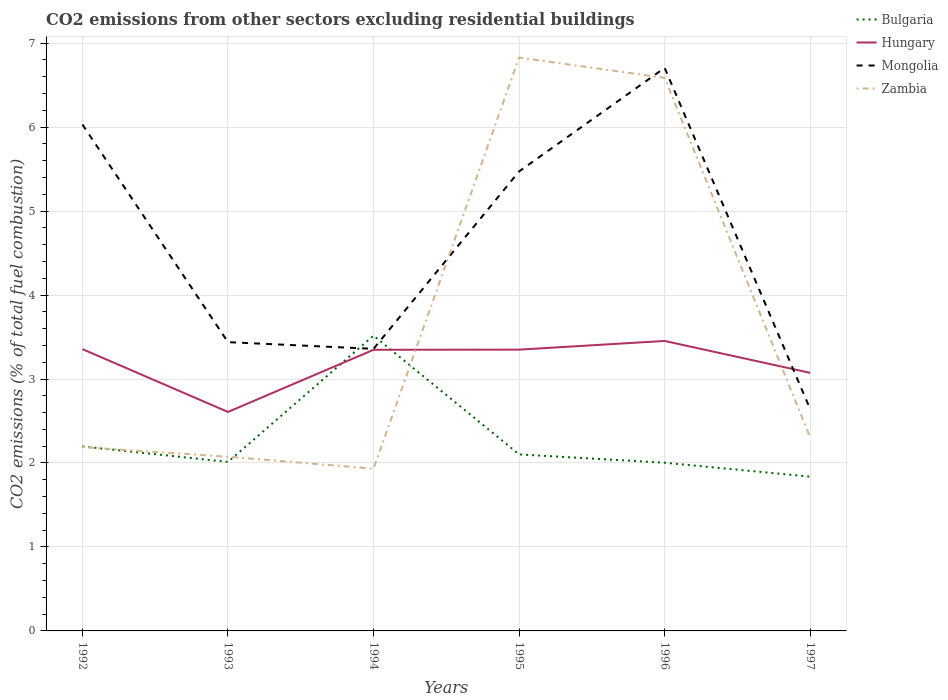Across all years, what is the maximum total CO2 emitted in Mongolia?
Your answer should be very brief. 2.64. In which year was the total CO2 emitted in Zambia maximum?
Provide a succinct answer. 1994. What is the total total CO2 emitted in Zambia in the graph?
Make the answer very short. -4.64. What is the difference between the highest and the second highest total CO2 emitted in Hungary?
Your answer should be compact. 0.85. Are the values on the major ticks of Y-axis written in scientific E-notation?
Ensure brevity in your answer.  No. Where does the legend appear in the graph?
Ensure brevity in your answer.  Top right. What is the title of the graph?
Offer a terse response. CO2 emissions from other sectors excluding residential buildings. What is the label or title of the X-axis?
Offer a very short reply. Years. What is the label or title of the Y-axis?
Your response must be concise. CO2 emissions (% of total fuel combustion). What is the CO2 emissions (% of total fuel combustion) in Bulgaria in 1992?
Offer a very short reply. 2.2. What is the CO2 emissions (% of total fuel combustion) of Hungary in 1992?
Your response must be concise. 3.36. What is the CO2 emissions (% of total fuel combustion) in Mongolia in 1992?
Provide a succinct answer. 6.03. What is the CO2 emissions (% of total fuel combustion) in Zambia in 1992?
Keep it short and to the point. 2.19. What is the CO2 emissions (% of total fuel combustion) in Bulgaria in 1993?
Make the answer very short. 2.01. What is the CO2 emissions (% of total fuel combustion) of Hungary in 1993?
Offer a terse response. 2.61. What is the CO2 emissions (% of total fuel combustion) of Mongolia in 1993?
Provide a short and direct response. 3.44. What is the CO2 emissions (% of total fuel combustion) in Zambia in 1993?
Provide a succinct answer. 2.07. What is the CO2 emissions (% of total fuel combustion) of Bulgaria in 1994?
Your response must be concise. 3.52. What is the CO2 emissions (% of total fuel combustion) of Hungary in 1994?
Keep it short and to the point. 3.35. What is the CO2 emissions (% of total fuel combustion) in Mongolia in 1994?
Offer a very short reply. 3.36. What is the CO2 emissions (% of total fuel combustion) in Zambia in 1994?
Ensure brevity in your answer.  1.93. What is the CO2 emissions (% of total fuel combustion) in Bulgaria in 1995?
Your answer should be very brief. 2.1. What is the CO2 emissions (% of total fuel combustion) in Hungary in 1995?
Give a very brief answer. 3.35. What is the CO2 emissions (% of total fuel combustion) of Mongolia in 1995?
Offer a terse response. 5.47. What is the CO2 emissions (% of total fuel combustion) in Zambia in 1995?
Give a very brief answer. 6.83. What is the CO2 emissions (% of total fuel combustion) of Bulgaria in 1996?
Make the answer very short. 2. What is the CO2 emissions (% of total fuel combustion) of Hungary in 1996?
Offer a terse response. 3.45. What is the CO2 emissions (% of total fuel combustion) of Mongolia in 1996?
Your answer should be very brief. 6.71. What is the CO2 emissions (% of total fuel combustion) in Zambia in 1996?
Offer a very short reply. 6.59. What is the CO2 emissions (% of total fuel combustion) in Bulgaria in 1997?
Give a very brief answer. 1.84. What is the CO2 emissions (% of total fuel combustion) in Hungary in 1997?
Your answer should be compact. 3.07. What is the CO2 emissions (% of total fuel combustion) of Mongolia in 1997?
Provide a short and direct response. 2.64. What is the CO2 emissions (% of total fuel combustion) of Zambia in 1997?
Provide a short and direct response. 2.3. Across all years, what is the maximum CO2 emissions (% of total fuel combustion) of Bulgaria?
Offer a terse response. 3.52. Across all years, what is the maximum CO2 emissions (% of total fuel combustion) in Hungary?
Keep it short and to the point. 3.45. Across all years, what is the maximum CO2 emissions (% of total fuel combustion) of Mongolia?
Provide a succinct answer. 6.71. Across all years, what is the maximum CO2 emissions (% of total fuel combustion) in Zambia?
Give a very brief answer. 6.83. Across all years, what is the minimum CO2 emissions (% of total fuel combustion) in Bulgaria?
Ensure brevity in your answer.  1.84. Across all years, what is the minimum CO2 emissions (% of total fuel combustion) in Hungary?
Provide a short and direct response. 2.61. Across all years, what is the minimum CO2 emissions (% of total fuel combustion) of Mongolia?
Offer a terse response. 2.64. Across all years, what is the minimum CO2 emissions (% of total fuel combustion) in Zambia?
Offer a very short reply. 1.93. What is the total CO2 emissions (% of total fuel combustion) in Bulgaria in the graph?
Your response must be concise. 13.67. What is the total CO2 emissions (% of total fuel combustion) in Hungary in the graph?
Provide a succinct answer. 19.19. What is the total CO2 emissions (% of total fuel combustion) in Mongolia in the graph?
Keep it short and to the point. 27.65. What is the total CO2 emissions (% of total fuel combustion) of Zambia in the graph?
Offer a very short reply. 21.92. What is the difference between the CO2 emissions (% of total fuel combustion) in Bulgaria in 1992 and that in 1993?
Ensure brevity in your answer.  0.18. What is the difference between the CO2 emissions (% of total fuel combustion) in Hungary in 1992 and that in 1993?
Your response must be concise. 0.75. What is the difference between the CO2 emissions (% of total fuel combustion) in Mongolia in 1992 and that in 1993?
Keep it short and to the point. 2.59. What is the difference between the CO2 emissions (% of total fuel combustion) in Zambia in 1992 and that in 1993?
Make the answer very short. 0.12. What is the difference between the CO2 emissions (% of total fuel combustion) of Bulgaria in 1992 and that in 1994?
Provide a short and direct response. -1.32. What is the difference between the CO2 emissions (% of total fuel combustion) in Hungary in 1992 and that in 1994?
Make the answer very short. 0.01. What is the difference between the CO2 emissions (% of total fuel combustion) in Mongolia in 1992 and that in 1994?
Ensure brevity in your answer.  2.67. What is the difference between the CO2 emissions (% of total fuel combustion) in Zambia in 1992 and that in 1994?
Give a very brief answer. 0.26. What is the difference between the CO2 emissions (% of total fuel combustion) of Bulgaria in 1992 and that in 1995?
Your answer should be very brief. 0.09. What is the difference between the CO2 emissions (% of total fuel combustion) in Hungary in 1992 and that in 1995?
Your answer should be very brief. 0.01. What is the difference between the CO2 emissions (% of total fuel combustion) in Mongolia in 1992 and that in 1995?
Offer a very short reply. 0.56. What is the difference between the CO2 emissions (% of total fuel combustion) of Zambia in 1992 and that in 1995?
Provide a succinct answer. -4.64. What is the difference between the CO2 emissions (% of total fuel combustion) in Bulgaria in 1992 and that in 1996?
Provide a succinct answer. 0.19. What is the difference between the CO2 emissions (% of total fuel combustion) of Hungary in 1992 and that in 1996?
Offer a terse response. -0.1. What is the difference between the CO2 emissions (% of total fuel combustion) in Mongolia in 1992 and that in 1996?
Give a very brief answer. -0.67. What is the difference between the CO2 emissions (% of total fuel combustion) in Zambia in 1992 and that in 1996?
Make the answer very short. -4.4. What is the difference between the CO2 emissions (% of total fuel combustion) in Bulgaria in 1992 and that in 1997?
Offer a very short reply. 0.36. What is the difference between the CO2 emissions (% of total fuel combustion) of Hungary in 1992 and that in 1997?
Offer a very short reply. 0.28. What is the difference between the CO2 emissions (% of total fuel combustion) in Mongolia in 1992 and that in 1997?
Your answer should be very brief. 3.39. What is the difference between the CO2 emissions (% of total fuel combustion) in Zambia in 1992 and that in 1997?
Provide a short and direct response. -0.11. What is the difference between the CO2 emissions (% of total fuel combustion) of Bulgaria in 1993 and that in 1994?
Offer a very short reply. -1.5. What is the difference between the CO2 emissions (% of total fuel combustion) of Hungary in 1993 and that in 1994?
Make the answer very short. -0.74. What is the difference between the CO2 emissions (% of total fuel combustion) of Mongolia in 1993 and that in 1994?
Make the answer very short. 0.08. What is the difference between the CO2 emissions (% of total fuel combustion) in Zambia in 1993 and that in 1994?
Provide a succinct answer. 0.14. What is the difference between the CO2 emissions (% of total fuel combustion) of Bulgaria in 1993 and that in 1995?
Make the answer very short. -0.09. What is the difference between the CO2 emissions (% of total fuel combustion) of Hungary in 1993 and that in 1995?
Ensure brevity in your answer.  -0.74. What is the difference between the CO2 emissions (% of total fuel combustion) in Mongolia in 1993 and that in 1995?
Your response must be concise. -2.03. What is the difference between the CO2 emissions (% of total fuel combustion) in Zambia in 1993 and that in 1995?
Your response must be concise. -4.75. What is the difference between the CO2 emissions (% of total fuel combustion) of Bulgaria in 1993 and that in 1996?
Offer a very short reply. 0.01. What is the difference between the CO2 emissions (% of total fuel combustion) in Hungary in 1993 and that in 1996?
Ensure brevity in your answer.  -0.85. What is the difference between the CO2 emissions (% of total fuel combustion) in Mongolia in 1993 and that in 1996?
Provide a succinct answer. -3.27. What is the difference between the CO2 emissions (% of total fuel combustion) in Zambia in 1993 and that in 1996?
Your answer should be very brief. -4.51. What is the difference between the CO2 emissions (% of total fuel combustion) of Bulgaria in 1993 and that in 1997?
Provide a short and direct response. 0.18. What is the difference between the CO2 emissions (% of total fuel combustion) in Hungary in 1993 and that in 1997?
Your answer should be very brief. -0.47. What is the difference between the CO2 emissions (% of total fuel combustion) in Mongolia in 1993 and that in 1997?
Offer a terse response. 0.8. What is the difference between the CO2 emissions (% of total fuel combustion) of Zambia in 1993 and that in 1997?
Provide a short and direct response. -0.23. What is the difference between the CO2 emissions (% of total fuel combustion) in Bulgaria in 1994 and that in 1995?
Provide a short and direct response. 1.41. What is the difference between the CO2 emissions (% of total fuel combustion) in Hungary in 1994 and that in 1995?
Your response must be concise. -0. What is the difference between the CO2 emissions (% of total fuel combustion) of Mongolia in 1994 and that in 1995?
Offer a terse response. -2.11. What is the difference between the CO2 emissions (% of total fuel combustion) of Zambia in 1994 and that in 1995?
Ensure brevity in your answer.  -4.9. What is the difference between the CO2 emissions (% of total fuel combustion) of Bulgaria in 1994 and that in 1996?
Ensure brevity in your answer.  1.51. What is the difference between the CO2 emissions (% of total fuel combustion) of Hungary in 1994 and that in 1996?
Offer a very short reply. -0.11. What is the difference between the CO2 emissions (% of total fuel combustion) in Mongolia in 1994 and that in 1996?
Offer a very short reply. -3.35. What is the difference between the CO2 emissions (% of total fuel combustion) of Zambia in 1994 and that in 1996?
Offer a very short reply. -4.65. What is the difference between the CO2 emissions (% of total fuel combustion) of Bulgaria in 1994 and that in 1997?
Your answer should be very brief. 1.68. What is the difference between the CO2 emissions (% of total fuel combustion) of Hungary in 1994 and that in 1997?
Make the answer very short. 0.27. What is the difference between the CO2 emissions (% of total fuel combustion) in Mongolia in 1994 and that in 1997?
Give a very brief answer. 0.72. What is the difference between the CO2 emissions (% of total fuel combustion) in Zambia in 1994 and that in 1997?
Provide a succinct answer. -0.37. What is the difference between the CO2 emissions (% of total fuel combustion) in Bulgaria in 1995 and that in 1996?
Ensure brevity in your answer.  0.1. What is the difference between the CO2 emissions (% of total fuel combustion) in Hungary in 1995 and that in 1996?
Offer a very short reply. -0.1. What is the difference between the CO2 emissions (% of total fuel combustion) in Mongolia in 1995 and that in 1996?
Offer a terse response. -1.23. What is the difference between the CO2 emissions (% of total fuel combustion) of Zambia in 1995 and that in 1996?
Your answer should be very brief. 0.24. What is the difference between the CO2 emissions (% of total fuel combustion) of Bulgaria in 1995 and that in 1997?
Offer a very short reply. 0.27. What is the difference between the CO2 emissions (% of total fuel combustion) of Hungary in 1995 and that in 1997?
Offer a terse response. 0.28. What is the difference between the CO2 emissions (% of total fuel combustion) of Mongolia in 1995 and that in 1997?
Provide a succinct answer. 2.83. What is the difference between the CO2 emissions (% of total fuel combustion) in Zambia in 1995 and that in 1997?
Make the answer very short. 4.53. What is the difference between the CO2 emissions (% of total fuel combustion) in Bulgaria in 1996 and that in 1997?
Ensure brevity in your answer.  0.17. What is the difference between the CO2 emissions (% of total fuel combustion) in Hungary in 1996 and that in 1997?
Offer a terse response. 0.38. What is the difference between the CO2 emissions (% of total fuel combustion) of Mongolia in 1996 and that in 1997?
Your answer should be compact. 4.06. What is the difference between the CO2 emissions (% of total fuel combustion) in Zambia in 1996 and that in 1997?
Make the answer very short. 4.28. What is the difference between the CO2 emissions (% of total fuel combustion) of Bulgaria in 1992 and the CO2 emissions (% of total fuel combustion) of Hungary in 1993?
Keep it short and to the point. -0.41. What is the difference between the CO2 emissions (% of total fuel combustion) in Bulgaria in 1992 and the CO2 emissions (% of total fuel combustion) in Mongolia in 1993?
Your answer should be compact. -1.24. What is the difference between the CO2 emissions (% of total fuel combustion) in Bulgaria in 1992 and the CO2 emissions (% of total fuel combustion) in Zambia in 1993?
Your answer should be very brief. 0.12. What is the difference between the CO2 emissions (% of total fuel combustion) in Hungary in 1992 and the CO2 emissions (% of total fuel combustion) in Mongolia in 1993?
Make the answer very short. -0.08. What is the difference between the CO2 emissions (% of total fuel combustion) of Hungary in 1992 and the CO2 emissions (% of total fuel combustion) of Zambia in 1993?
Offer a terse response. 1.28. What is the difference between the CO2 emissions (% of total fuel combustion) of Mongolia in 1992 and the CO2 emissions (% of total fuel combustion) of Zambia in 1993?
Make the answer very short. 3.96. What is the difference between the CO2 emissions (% of total fuel combustion) in Bulgaria in 1992 and the CO2 emissions (% of total fuel combustion) in Hungary in 1994?
Provide a succinct answer. -1.15. What is the difference between the CO2 emissions (% of total fuel combustion) in Bulgaria in 1992 and the CO2 emissions (% of total fuel combustion) in Mongolia in 1994?
Your answer should be very brief. -1.16. What is the difference between the CO2 emissions (% of total fuel combustion) in Bulgaria in 1992 and the CO2 emissions (% of total fuel combustion) in Zambia in 1994?
Your answer should be very brief. 0.26. What is the difference between the CO2 emissions (% of total fuel combustion) in Hungary in 1992 and the CO2 emissions (% of total fuel combustion) in Mongolia in 1994?
Make the answer very short. -0. What is the difference between the CO2 emissions (% of total fuel combustion) of Hungary in 1992 and the CO2 emissions (% of total fuel combustion) of Zambia in 1994?
Provide a short and direct response. 1.42. What is the difference between the CO2 emissions (% of total fuel combustion) of Mongolia in 1992 and the CO2 emissions (% of total fuel combustion) of Zambia in 1994?
Your answer should be compact. 4.1. What is the difference between the CO2 emissions (% of total fuel combustion) in Bulgaria in 1992 and the CO2 emissions (% of total fuel combustion) in Hungary in 1995?
Ensure brevity in your answer.  -1.15. What is the difference between the CO2 emissions (% of total fuel combustion) in Bulgaria in 1992 and the CO2 emissions (% of total fuel combustion) in Mongolia in 1995?
Make the answer very short. -3.28. What is the difference between the CO2 emissions (% of total fuel combustion) in Bulgaria in 1992 and the CO2 emissions (% of total fuel combustion) in Zambia in 1995?
Your response must be concise. -4.63. What is the difference between the CO2 emissions (% of total fuel combustion) in Hungary in 1992 and the CO2 emissions (% of total fuel combustion) in Mongolia in 1995?
Offer a terse response. -2.12. What is the difference between the CO2 emissions (% of total fuel combustion) of Hungary in 1992 and the CO2 emissions (% of total fuel combustion) of Zambia in 1995?
Give a very brief answer. -3.47. What is the difference between the CO2 emissions (% of total fuel combustion) in Mongolia in 1992 and the CO2 emissions (% of total fuel combustion) in Zambia in 1995?
Your answer should be very brief. -0.8. What is the difference between the CO2 emissions (% of total fuel combustion) of Bulgaria in 1992 and the CO2 emissions (% of total fuel combustion) of Hungary in 1996?
Keep it short and to the point. -1.26. What is the difference between the CO2 emissions (% of total fuel combustion) in Bulgaria in 1992 and the CO2 emissions (% of total fuel combustion) in Mongolia in 1996?
Provide a short and direct response. -4.51. What is the difference between the CO2 emissions (% of total fuel combustion) in Bulgaria in 1992 and the CO2 emissions (% of total fuel combustion) in Zambia in 1996?
Offer a terse response. -4.39. What is the difference between the CO2 emissions (% of total fuel combustion) of Hungary in 1992 and the CO2 emissions (% of total fuel combustion) of Mongolia in 1996?
Make the answer very short. -3.35. What is the difference between the CO2 emissions (% of total fuel combustion) of Hungary in 1992 and the CO2 emissions (% of total fuel combustion) of Zambia in 1996?
Your answer should be compact. -3.23. What is the difference between the CO2 emissions (% of total fuel combustion) of Mongolia in 1992 and the CO2 emissions (% of total fuel combustion) of Zambia in 1996?
Make the answer very short. -0.56. What is the difference between the CO2 emissions (% of total fuel combustion) of Bulgaria in 1992 and the CO2 emissions (% of total fuel combustion) of Hungary in 1997?
Ensure brevity in your answer.  -0.88. What is the difference between the CO2 emissions (% of total fuel combustion) in Bulgaria in 1992 and the CO2 emissions (% of total fuel combustion) in Mongolia in 1997?
Ensure brevity in your answer.  -0.44. What is the difference between the CO2 emissions (% of total fuel combustion) of Bulgaria in 1992 and the CO2 emissions (% of total fuel combustion) of Zambia in 1997?
Give a very brief answer. -0.11. What is the difference between the CO2 emissions (% of total fuel combustion) in Hungary in 1992 and the CO2 emissions (% of total fuel combustion) in Mongolia in 1997?
Your answer should be very brief. 0.72. What is the difference between the CO2 emissions (% of total fuel combustion) of Hungary in 1992 and the CO2 emissions (% of total fuel combustion) of Zambia in 1997?
Your answer should be very brief. 1.05. What is the difference between the CO2 emissions (% of total fuel combustion) in Mongolia in 1992 and the CO2 emissions (% of total fuel combustion) in Zambia in 1997?
Your answer should be very brief. 3.73. What is the difference between the CO2 emissions (% of total fuel combustion) of Bulgaria in 1993 and the CO2 emissions (% of total fuel combustion) of Hungary in 1994?
Ensure brevity in your answer.  -1.34. What is the difference between the CO2 emissions (% of total fuel combustion) of Bulgaria in 1993 and the CO2 emissions (% of total fuel combustion) of Mongolia in 1994?
Ensure brevity in your answer.  -1.35. What is the difference between the CO2 emissions (% of total fuel combustion) in Bulgaria in 1993 and the CO2 emissions (% of total fuel combustion) in Zambia in 1994?
Ensure brevity in your answer.  0.08. What is the difference between the CO2 emissions (% of total fuel combustion) in Hungary in 1993 and the CO2 emissions (% of total fuel combustion) in Mongolia in 1994?
Provide a short and direct response. -0.75. What is the difference between the CO2 emissions (% of total fuel combustion) in Hungary in 1993 and the CO2 emissions (% of total fuel combustion) in Zambia in 1994?
Offer a very short reply. 0.68. What is the difference between the CO2 emissions (% of total fuel combustion) in Mongolia in 1993 and the CO2 emissions (% of total fuel combustion) in Zambia in 1994?
Offer a terse response. 1.51. What is the difference between the CO2 emissions (% of total fuel combustion) of Bulgaria in 1993 and the CO2 emissions (% of total fuel combustion) of Hungary in 1995?
Your answer should be compact. -1.34. What is the difference between the CO2 emissions (% of total fuel combustion) of Bulgaria in 1993 and the CO2 emissions (% of total fuel combustion) of Mongolia in 1995?
Provide a succinct answer. -3.46. What is the difference between the CO2 emissions (% of total fuel combustion) of Bulgaria in 1993 and the CO2 emissions (% of total fuel combustion) of Zambia in 1995?
Offer a very short reply. -4.82. What is the difference between the CO2 emissions (% of total fuel combustion) of Hungary in 1993 and the CO2 emissions (% of total fuel combustion) of Mongolia in 1995?
Offer a very short reply. -2.86. What is the difference between the CO2 emissions (% of total fuel combustion) in Hungary in 1993 and the CO2 emissions (% of total fuel combustion) in Zambia in 1995?
Give a very brief answer. -4.22. What is the difference between the CO2 emissions (% of total fuel combustion) in Mongolia in 1993 and the CO2 emissions (% of total fuel combustion) in Zambia in 1995?
Offer a terse response. -3.39. What is the difference between the CO2 emissions (% of total fuel combustion) of Bulgaria in 1993 and the CO2 emissions (% of total fuel combustion) of Hungary in 1996?
Offer a very short reply. -1.44. What is the difference between the CO2 emissions (% of total fuel combustion) of Bulgaria in 1993 and the CO2 emissions (% of total fuel combustion) of Mongolia in 1996?
Offer a very short reply. -4.69. What is the difference between the CO2 emissions (% of total fuel combustion) in Bulgaria in 1993 and the CO2 emissions (% of total fuel combustion) in Zambia in 1996?
Give a very brief answer. -4.57. What is the difference between the CO2 emissions (% of total fuel combustion) of Hungary in 1993 and the CO2 emissions (% of total fuel combustion) of Mongolia in 1996?
Your answer should be very brief. -4.1. What is the difference between the CO2 emissions (% of total fuel combustion) of Hungary in 1993 and the CO2 emissions (% of total fuel combustion) of Zambia in 1996?
Make the answer very short. -3.98. What is the difference between the CO2 emissions (% of total fuel combustion) in Mongolia in 1993 and the CO2 emissions (% of total fuel combustion) in Zambia in 1996?
Provide a succinct answer. -3.15. What is the difference between the CO2 emissions (% of total fuel combustion) of Bulgaria in 1993 and the CO2 emissions (% of total fuel combustion) of Hungary in 1997?
Give a very brief answer. -1.06. What is the difference between the CO2 emissions (% of total fuel combustion) in Bulgaria in 1993 and the CO2 emissions (% of total fuel combustion) in Mongolia in 1997?
Keep it short and to the point. -0.63. What is the difference between the CO2 emissions (% of total fuel combustion) in Bulgaria in 1993 and the CO2 emissions (% of total fuel combustion) in Zambia in 1997?
Provide a short and direct response. -0.29. What is the difference between the CO2 emissions (% of total fuel combustion) of Hungary in 1993 and the CO2 emissions (% of total fuel combustion) of Mongolia in 1997?
Provide a succinct answer. -0.03. What is the difference between the CO2 emissions (% of total fuel combustion) in Hungary in 1993 and the CO2 emissions (% of total fuel combustion) in Zambia in 1997?
Your answer should be compact. 0.3. What is the difference between the CO2 emissions (% of total fuel combustion) of Mongolia in 1993 and the CO2 emissions (% of total fuel combustion) of Zambia in 1997?
Give a very brief answer. 1.14. What is the difference between the CO2 emissions (% of total fuel combustion) in Bulgaria in 1994 and the CO2 emissions (% of total fuel combustion) in Hungary in 1995?
Offer a terse response. 0.17. What is the difference between the CO2 emissions (% of total fuel combustion) in Bulgaria in 1994 and the CO2 emissions (% of total fuel combustion) in Mongolia in 1995?
Make the answer very short. -1.96. What is the difference between the CO2 emissions (% of total fuel combustion) in Bulgaria in 1994 and the CO2 emissions (% of total fuel combustion) in Zambia in 1995?
Your answer should be very brief. -3.31. What is the difference between the CO2 emissions (% of total fuel combustion) of Hungary in 1994 and the CO2 emissions (% of total fuel combustion) of Mongolia in 1995?
Your response must be concise. -2.12. What is the difference between the CO2 emissions (% of total fuel combustion) in Hungary in 1994 and the CO2 emissions (% of total fuel combustion) in Zambia in 1995?
Offer a terse response. -3.48. What is the difference between the CO2 emissions (% of total fuel combustion) of Mongolia in 1994 and the CO2 emissions (% of total fuel combustion) of Zambia in 1995?
Offer a very short reply. -3.47. What is the difference between the CO2 emissions (% of total fuel combustion) in Bulgaria in 1994 and the CO2 emissions (% of total fuel combustion) in Hungary in 1996?
Give a very brief answer. 0.06. What is the difference between the CO2 emissions (% of total fuel combustion) of Bulgaria in 1994 and the CO2 emissions (% of total fuel combustion) of Mongolia in 1996?
Your response must be concise. -3.19. What is the difference between the CO2 emissions (% of total fuel combustion) of Bulgaria in 1994 and the CO2 emissions (% of total fuel combustion) of Zambia in 1996?
Provide a succinct answer. -3.07. What is the difference between the CO2 emissions (% of total fuel combustion) in Hungary in 1994 and the CO2 emissions (% of total fuel combustion) in Mongolia in 1996?
Keep it short and to the point. -3.36. What is the difference between the CO2 emissions (% of total fuel combustion) in Hungary in 1994 and the CO2 emissions (% of total fuel combustion) in Zambia in 1996?
Provide a short and direct response. -3.24. What is the difference between the CO2 emissions (% of total fuel combustion) in Mongolia in 1994 and the CO2 emissions (% of total fuel combustion) in Zambia in 1996?
Give a very brief answer. -3.23. What is the difference between the CO2 emissions (% of total fuel combustion) in Bulgaria in 1994 and the CO2 emissions (% of total fuel combustion) in Hungary in 1997?
Offer a very short reply. 0.44. What is the difference between the CO2 emissions (% of total fuel combustion) of Bulgaria in 1994 and the CO2 emissions (% of total fuel combustion) of Mongolia in 1997?
Give a very brief answer. 0.88. What is the difference between the CO2 emissions (% of total fuel combustion) of Bulgaria in 1994 and the CO2 emissions (% of total fuel combustion) of Zambia in 1997?
Offer a very short reply. 1.21. What is the difference between the CO2 emissions (% of total fuel combustion) in Hungary in 1994 and the CO2 emissions (% of total fuel combustion) in Mongolia in 1997?
Your answer should be very brief. 0.71. What is the difference between the CO2 emissions (% of total fuel combustion) in Hungary in 1994 and the CO2 emissions (% of total fuel combustion) in Zambia in 1997?
Ensure brevity in your answer.  1.04. What is the difference between the CO2 emissions (% of total fuel combustion) of Mongolia in 1994 and the CO2 emissions (% of total fuel combustion) of Zambia in 1997?
Your response must be concise. 1.06. What is the difference between the CO2 emissions (% of total fuel combustion) of Bulgaria in 1995 and the CO2 emissions (% of total fuel combustion) of Hungary in 1996?
Provide a short and direct response. -1.35. What is the difference between the CO2 emissions (% of total fuel combustion) in Bulgaria in 1995 and the CO2 emissions (% of total fuel combustion) in Mongolia in 1996?
Ensure brevity in your answer.  -4.6. What is the difference between the CO2 emissions (% of total fuel combustion) in Bulgaria in 1995 and the CO2 emissions (% of total fuel combustion) in Zambia in 1996?
Ensure brevity in your answer.  -4.48. What is the difference between the CO2 emissions (% of total fuel combustion) of Hungary in 1995 and the CO2 emissions (% of total fuel combustion) of Mongolia in 1996?
Your response must be concise. -3.36. What is the difference between the CO2 emissions (% of total fuel combustion) in Hungary in 1995 and the CO2 emissions (% of total fuel combustion) in Zambia in 1996?
Provide a short and direct response. -3.24. What is the difference between the CO2 emissions (% of total fuel combustion) in Mongolia in 1995 and the CO2 emissions (% of total fuel combustion) in Zambia in 1996?
Give a very brief answer. -1.11. What is the difference between the CO2 emissions (% of total fuel combustion) in Bulgaria in 1995 and the CO2 emissions (% of total fuel combustion) in Hungary in 1997?
Your answer should be compact. -0.97. What is the difference between the CO2 emissions (% of total fuel combustion) in Bulgaria in 1995 and the CO2 emissions (% of total fuel combustion) in Mongolia in 1997?
Offer a very short reply. -0.54. What is the difference between the CO2 emissions (% of total fuel combustion) of Bulgaria in 1995 and the CO2 emissions (% of total fuel combustion) of Zambia in 1997?
Keep it short and to the point. -0.2. What is the difference between the CO2 emissions (% of total fuel combustion) in Hungary in 1995 and the CO2 emissions (% of total fuel combustion) in Mongolia in 1997?
Make the answer very short. 0.71. What is the difference between the CO2 emissions (% of total fuel combustion) in Hungary in 1995 and the CO2 emissions (% of total fuel combustion) in Zambia in 1997?
Give a very brief answer. 1.05. What is the difference between the CO2 emissions (% of total fuel combustion) in Mongolia in 1995 and the CO2 emissions (% of total fuel combustion) in Zambia in 1997?
Offer a very short reply. 3.17. What is the difference between the CO2 emissions (% of total fuel combustion) in Bulgaria in 1996 and the CO2 emissions (% of total fuel combustion) in Hungary in 1997?
Your response must be concise. -1.07. What is the difference between the CO2 emissions (% of total fuel combustion) of Bulgaria in 1996 and the CO2 emissions (% of total fuel combustion) of Mongolia in 1997?
Offer a very short reply. -0.64. What is the difference between the CO2 emissions (% of total fuel combustion) of Bulgaria in 1996 and the CO2 emissions (% of total fuel combustion) of Zambia in 1997?
Provide a short and direct response. -0.3. What is the difference between the CO2 emissions (% of total fuel combustion) of Hungary in 1996 and the CO2 emissions (% of total fuel combustion) of Mongolia in 1997?
Your answer should be very brief. 0.81. What is the difference between the CO2 emissions (% of total fuel combustion) of Hungary in 1996 and the CO2 emissions (% of total fuel combustion) of Zambia in 1997?
Provide a short and direct response. 1.15. What is the difference between the CO2 emissions (% of total fuel combustion) in Mongolia in 1996 and the CO2 emissions (% of total fuel combustion) in Zambia in 1997?
Make the answer very short. 4.4. What is the average CO2 emissions (% of total fuel combustion) of Bulgaria per year?
Offer a terse response. 2.28. What is the average CO2 emissions (% of total fuel combustion) of Hungary per year?
Your response must be concise. 3.2. What is the average CO2 emissions (% of total fuel combustion) in Mongolia per year?
Give a very brief answer. 4.61. What is the average CO2 emissions (% of total fuel combustion) in Zambia per year?
Provide a short and direct response. 3.65. In the year 1992, what is the difference between the CO2 emissions (% of total fuel combustion) in Bulgaria and CO2 emissions (% of total fuel combustion) in Hungary?
Make the answer very short. -1.16. In the year 1992, what is the difference between the CO2 emissions (% of total fuel combustion) of Bulgaria and CO2 emissions (% of total fuel combustion) of Mongolia?
Make the answer very short. -3.83. In the year 1992, what is the difference between the CO2 emissions (% of total fuel combustion) in Bulgaria and CO2 emissions (% of total fuel combustion) in Zambia?
Your answer should be very brief. 0.01. In the year 1992, what is the difference between the CO2 emissions (% of total fuel combustion) of Hungary and CO2 emissions (% of total fuel combustion) of Mongolia?
Provide a short and direct response. -2.68. In the year 1992, what is the difference between the CO2 emissions (% of total fuel combustion) of Hungary and CO2 emissions (% of total fuel combustion) of Zambia?
Offer a very short reply. 1.17. In the year 1992, what is the difference between the CO2 emissions (% of total fuel combustion) of Mongolia and CO2 emissions (% of total fuel combustion) of Zambia?
Ensure brevity in your answer.  3.84. In the year 1993, what is the difference between the CO2 emissions (% of total fuel combustion) of Bulgaria and CO2 emissions (% of total fuel combustion) of Hungary?
Provide a succinct answer. -0.6. In the year 1993, what is the difference between the CO2 emissions (% of total fuel combustion) in Bulgaria and CO2 emissions (% of total fuel combustion) in Mongolia?
Give a very brief answer. -1.43. In the year 1993, what is the difference between the CO2 emissions (% of total fuel combustion) in Bulgaria and CO2 emissions (% of total fuel combustion) in Zambia?
Keep it short and to the point. -0.06. In the year 1993, what is the difference between the CO2 emissions (% of total fuel combustion) in Hungary and CO2 emissions (% of total fuel combustion) in Mongolia?
Your answer should be compact. -0.83. In the year 1993, what is the difference between the CO2 emissions (% of total fuel combustion) in Hungary and CO2 emissions (% of total fuel combustion) in Zambia?
Provide a succinct answer. 0.53. In the year 1993, what is the difference between the CO2 emissions (% of total fuel combustion) of Mongolia and CO2 emissions (% of total fuel combustion) of Zambia?
Your answer should be compact. 1.36. In the year 1994, what is the difference between the CO2 emissions (% of total fuel combustion) of Bulgaria and CO2 emissions (% of total fuel combustion) of Hungary?
Your answer should be compact. 0.17. In the year 1994, what is the difference between the CO2 emissions (% of total fuel combustion) in Bulgaria and CO2 emissions (% of total fuel combustion) in Mongolia?
Your answer should be compact. 0.16. In the year 1994, what is the difference between the CO2 emissions (% of total fuel combustion) in Bulgaria and CO2 emissions (% of total fuel combustion) in Zambia?
Make the answer very short. 1.58. In the year 1994, what is the difference between the CO2 emissions (% of total fuel combustion) of Hungary and CO2 emissions (% of total fuel combustion) of Mongolia?
Provide a succinct answer. -0.01. In the year 1994, what is the difference between the CO2 emissions (% of total fuel combustion) of Hungary and CO2 emissions (% of total fuel combustion) of Zambia?
Give a very brief answer. 1.42. In the year 1994, what is the difference between the CO2 emissions (% of total fuel combustion) of Mongolia and CO2 emissions (% of total fuel combustion) of Zambia?
Provide a short and direct response. 1.43. In the year 1995, what is the difference between the CO2 emissions (% of total fuel combustion) of Bulgaria and CO2 emissions (% of total fuel combustion) of Hungary?
Keep it short and to the point. -1.25. In the year 1995, what is the difference between the CO2 emissions (% of total fuel combustion) of Bulgaria and CO2 emissions (% of total fuel combustion) of Mongolia?
Offer a terse response. -3.37. In the year 1995, what is the difference between the CO2 emissions (% of total fuel combustion) in Bulgaria and CO2 emissions (% of total fuel combustion) in Zambia?
Offer a terse response. -4.73. In the year 1995, what is the difference between the CO2 emissions (% of total fuel combustion) of Hungary and CO2 emissions (% of total fuel combustion) of Mongolia?
Your response must be concise. -2.12. In the year 1995, what is the difference between the CO2 emissions (% of total fuel combustion) in Hungary and CO2 emissions (% of total fuel combustion) in Zambia?
Make the answer very short. -3.48. In the year 1995, what is the difference between the CO2 emissions (% of total fuel combustion) of Mongolia and CO2 emissions (% of total fuel combustion) of Zambia?
Your answer should be very brief. -1.36. In the year 1996, what is the difference between the CO2 emissions (% of total fuel combustion) of Bulgaria and CO2 emissions (% of total fuel combustion) of Hungary?
Offer a terse response. -1.45. In the year 1996, what is the difference between the CO2 emissions (% of total fuel combustion) of Bulgaria and CO2 emissions (% of total fuel combustion) of Mongolia?
Give a very brief answer. -4.7. In the year 1996, what is the difference between the CO2 emissions (% of total fuel combustion) of Bulgaria and CO2 emissions (% of total fuel combustion) of Zambia?
Offer a very short reply. -4.58. In the year 1996, what is the difference between the CO2 emissions (% of total fuel combustion) in Hungary and CO2 emissions (% of total fuel combustion) in Mongolia?
Your answer should be compact. -3.25. In the year 1996, what is the difference between the CO2 emissions (% of total fuel combustion) in Hungary and CO2 emissions (% of total fuel combustion) in Zambia?
Keep it short and to the point. -3.13. In the year 1996, what is the difference between the CO2 emissions (% of total fuel combustion) in Mongolia and CO2 emissions (% of total fuel combustion) in Zambia?
Make the answer very short. 0.12. In the year 1997, what is the difference between the CO2 emissions (% of total fuel combustion) in Bulgaria and CO2 emissions (% of total fuel combustion) in Hungary?
Offer a very short reply. -1.24. In the year 1997, what is the difference between the CO2 emissions (% of total fuel combustion) in Bulgaria and CO2 emissions (% of total fuel combustion) in Mongolia?
Your answer should be very brief. -0.8. In the year 1997, what is the difference between the CO2 emissions (% of total fuel combustion) in Bulgaria and CO2 emissions (% of total fuel combustion) in Zambia?
Offer a very short reply. -0.47. In the year 1997, what is the difference between the CO2 emissions (% of total fuel combustion) in Hungary and CO2 emissions (% of total fuel combustion) in Mongolia?
Give a very brief answer. 0.43. In the year 1997, what is the difference between the CO2 emissions (% of total fuel combustion) in Hungary and CO2 emissions (% of total fuel combustion) in Zambia?
Keep it short and to the point. 0.77. In the year 1997, what is the difference between the CO2 emissions (% of total fuel combustion) of Mongolia and CO2 emissions (% of total fuel combustion) of Zambia?
Make the answer very short. 0.34. What is the ratio of the CO2 emissions (% of total fuel combustion) in Bulgaria in 1992 to that in 1993?
Your response must be concise. 1.09. What is the ratio of the CO2 emissions (% of total fuel combustion) in Hungary in 1992 to that in 1993?
Your response must be concise. 1.29. What is the ratio of the CO2 emissions (% of total fuel combustion) in Mongolia in 1992 to that in 1993?
Keep it short and to the point. 1.75. What is the ratio of the CO2 emissions (% of total fuel combustion) of Zambia in 1992 to that in 1993?
Offer a very short reply. 1.06. What is the ratio of the CO2 emissions (% of total fuel combustion) in Bulgaria in 1992 to that in 1994?
Provide a succinct answer. 0.62. What is the ratio of the CO2 emissions (% of total fuel combustion) in Mongolia in 1992 to that in 1994?
Keep it short and to the point. 1.8. What is the ratio of the CO2 emissions (% of total fuel combustion) in Zambia in 1992 to that in 1994?
Provide a short and direct response. 1.13. What is the ratio of the CO2 emissions (% of total fuel combustion) of Bulgaria in 1992 to that in 1995?
Offer a very short reply. 1.04. What is the ratio of the CO2 emissions (% of total fuel combustion) in Hungary in 1992 to that in 1995?
Provide a succinct answer. 1. What is the ratio of the CO2 emissions (% of total fuel combustion) of Mongolia in 1992 to that in 1995?
Ensure brevity in your answer.  1.1. What is the ratio of the CO2 emissions (% of total fuel combustion) of Zambia in 1992 to that in 1995?
Provide a short and direct response. 0.32. What is the ratio of the CO2 emissions (% of total fuel combustion) in Bulgaria in 1992 to that in 1996?
Your answer should be very brief. 1.1. What is the ratio of the CO2 emissions (% of total fuel combustion) in Hungary in 1992 to that in 1996?
Provide a short and direct response. 0.97. What is the ratio of the CO2 emissions (% of total fuel combustion) of Mongolia in 1992 to that in 1996?
Give a very brief answer. 0.9. What is the ratio of the CO2 emissions (% of total fuel combustion) of Zambia in 1992 to that in 1996?
Ensure brevity in your answer.  0.33. What is the ratio of the CO2 emissions (% of total fuel combustion) in Bulgaria in 1992 to that in 1997?
Your answer should be compact. 1.2. What is the ratio of the CO2 emissions (% of total fuel combustion) of Hungary in 1992 to that in 1997?
Your answer should be very brief. 1.09. What is the ratio of the CO2 emissions (% of total fuel combustion) of Mongolia in 1992 to that in 1997?
Keep it short and to the point. 2.28. What is the ratio of the CO2 emissions (% of total fuel combustion) in Zambia in 1992 to that in 1997?
Your answer should be very brief. 0.95. What is the ratio of the CO2 emissions (% of total fuel combustion) in Bulgaria in 1993 to that in 1994?
Offer a terse response. 0.57. What is the ratio of the CO2 emissions (% of total fuel combustion) in Hungary in 1993 to that in 1994?
Provide a short and direct response. 0.78. What is the ratio of the CO2 emissions (% of total fuel combustion) in Mongolia in 1993 to that in 1994?
Your answer should be compact. 1.02. What is the ratio of the CO2 emissions (% of total fuel combustion) in Zambia in 1993 to that in 1994?
Your response must be concise. 1.07. What is the ratio of the CO2 emissions (% of total fuel combustion) in Bulgaria in 1993 to that in 1995?
Provide a short and direct response. 0.96. What is the ratio of the CO2 emissions (% of total fuel combustion) of Hungary in 1993 to that in 1995?
Offer a terse response. 0.78. What is the ratio of the CO2 emissions (% of total fuel combustion) of Mongolia in 1993 to that in 1995?
Offer a very short reply. 0.63. What is the ratio of the CO2 emissions (% of total fuel combustion) in Zambia in 1993 to that in 1995?
Offer a very short reply. 0.3. What is the ratio of the CO2 emissions (% of total fuel combustion) of Hungary in 1993 to that in 1996?
Your response must be concise. 0.76. What is the ratio of the CO2 emissions (% of total fuel combustion) of Mongolia in 1993 to that in 1996?
Your response must be concise. 0.51. What is the ratio of the CO2 emissions (% of total fuel combustion) in Zambia in 1993 to that in 1996?
Offer a terse response. 0.32. What is the ratio of the CO2 emissions (% of total fuel combustion) of Bulgaria in 1993 to that in 1997?
Offer a terse response. 1.1. What is the ratio of the CO2 emissions (% of total fuel combustion) of Hungary in 1993 to that in 1997?
Ensure brevity in your answer.  0.85. What is the ratio of the CO2 emissions (% of total fuel combustion) of Mongolia in 1993 to that in 1997?
Your answer should be compact. 1.3. What is the ratio of the CO2 emissions (% of total fuel combustion) of Zambia in 1993 to that in 1997?
Your answer should be very brief. 0.9. What is the ratio of the CO2 emissions (% of total fuel combustion) in Bulgaria in 1994 to that in 1995?
Make the answer very short. 1.67. What is the ratio of the CO2 emissions (% of total fuel combustion) in Hungary in 1994 to that in 1995?
Your answer should be very brief. 1. What is the ratio of the CO2 emissions (% of total fuel combustion) of Mongolia in 1994 to that in 1995?
Provide a succinct answer. 0.61. What is the ratio of the CO2 emissions (% of total fuel combustion) of Zambia in 1994 to that in 1995?
Offer a very short reply. 0.28. What is the ratio of the CO2 emissions (% of total fuel combustion) of Bulgaria in 1994 to that in 1996?
Your answer should be compact. 1.76. What is the ratio of the CO2 emissions (% of total fuel combustion) of Hungary in 1994 to that in 1996?
Keep it short and to the point. 0.97. What is the ratio of the CO2 emissions (% of total fuel combustion) of Mongolia in 1994 to that in 1996?
Ensure brevity in your answer.  0.5. What is the ratio of the CO2 emissions (% of total fuel combustion) in Zambia in 1994 to that in 1996?
Your response must be concise. 0.29. What is the ratio of the CO2 emissions (% of total fuel combustion) in Bulgaria in 1994 to that in 1997?
Offer a terse response. 1.91. What is the ratio of the CO2 emissions (% of total fuel combustion) of Hungary in 1994 to that in 1997?
Provide a short and direct response. 1.09. What is the ratio of the CO2 emissions (% of total fuel combustion) of Mongolia in 1994 to that in 1997?
Give a very brief answer. 1.27. What is the ratio of the CO2 emissions (% of total fuel combustion) in Zambia in 1994 to that in 1997?
Your response must be concise. 0.84. What is the ratio of the CO2 emissions (% of total fuel combustion) in Bulgaria in 1995 to that in 1996?
Offer a very short reply. 1.05. What is the ratio of the CO2 emissions (% of total fuel combustion) in Hungary in 1995 to that in 1996?
Keep it short and to the point. 0.97. What is the ratio of the CO2 emissions (% of total fuel combustion) in Mongolia in 1995 to that in 1996?
Ensure brevity in your answer.  0.82. What is the ratio of the CO2 emissions (% of total fuel combustion) in Zambia in 1995 to that in 1996?
Give a very brief answer. 1.04. What is the ratio of the CO2 emissions (% of total fuel combustion) in Bulgaria in 1995 to that in 1997?
Give a very brief answer. 1.14. What is the ratio of the CO2 emissions (% of total fuel combustion) of Hungary in 1995 to that in 1997?
Your answer should be compact. 1.09. What is the ratio of the CO2 emissions (% of total fuel combustion) of Mongolia in 1995 to that in 1997?
Make the answer very short. 2.07. What is the ratio of the CO2 emissions (% of total fuel combustion) in Zambia in 1995 to that in 1997?
Make the answer very short. 2.96. What is the ratio of the CO2 emissions (% of total fuel combustion) of Bulgaria in 1996 to that in 1997?
Ensure brevity in your answer.  1.09. What is the ratio of the CO2 emissions (% of total fuel combustion) in Hungary in 1996 to that in 1997?
Keep it short and to the point. 1.12. What is the ratio of the CO2 emissions (% of total fuel combustion) of Mongolia in 1996 to that in 1997?
Provide a succinct answer. 2.54. What is the ratio of the CO2 emissions (% of total fuel combustion) of Zambia in 1996 to that in 1997?
Make the answer very short. 2.86. What is the difference between the highest and the second highest CO2 emissions (% of total fuel combustion) of Bulgaria?
Give a very brief answer. 1.32. What is the difference between the highest and the second highest CO2 emissions (% of total fuel combustion) of Hungary?
Offer a very short reply. 0.1. What is the difference between the highest and the second highest CO2 emissions (% of total fuel combustion) in Mongolia?
Provide a succinct answer. 0.67. What is the difference between the highest and the second highest CO2 emissions (% of total fuel combustion) in Zambia?
Keep it short and to the point. 0.24. What is the difference between the highest and the lowest CO2 emissions (% of total fuel combustion) in Bulgaria?
Provide a short and direct response. 1.68. What is the difference between the highest and the lowest CO2 emissions (% of total fuel combustion) of Hungary?
Make the answer very short. 0.85. What is the difference between the highest and the lowest CO2 emissions (% of total fuel combustion) in Mongolia?
Provide a short and direct response. 4.06. What is the difference between the highest and the lowest CO2 emissions (% of total fuel combustion) in Zambia?
Your answer should be compact. 4.9. 